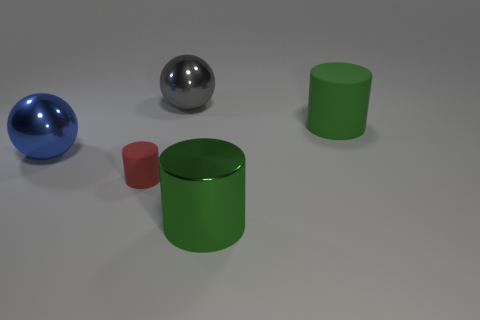Add 1 small matte cylinders. How many objects exist? 6 Subtract all spheres. How many objects are left? 3 Add 2 big gray matte objects. How many big gray matte objects exist? 2 Subtract 0 yellow cubes. How many objects are left? 5 Subtract all metallic cylinders. Subtract all large metallic spheres. How many objects are left? 2 Add 3 small rubber cylinders. How many small rubber cylinders are left? 4 